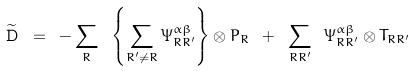<formula> <loc_0><loc_0><loc_500><loc_500>\widetilde { \mathbf D } \ = \ - \sum _ { R } \ \left \{ \sum _ { R ^ { \prime } \ne R } \Psi _ { R R ^ { \prime } } ^ { \alpha \beta } \right \} \otimes P _ { R } \ + \ \sum _ { R R ^ { \prime } } \ \Psi _ { R R ^ { \prime } } ^ { \alpha \beta } \otimes T _ { R R ^ { \prime } }</formula> 